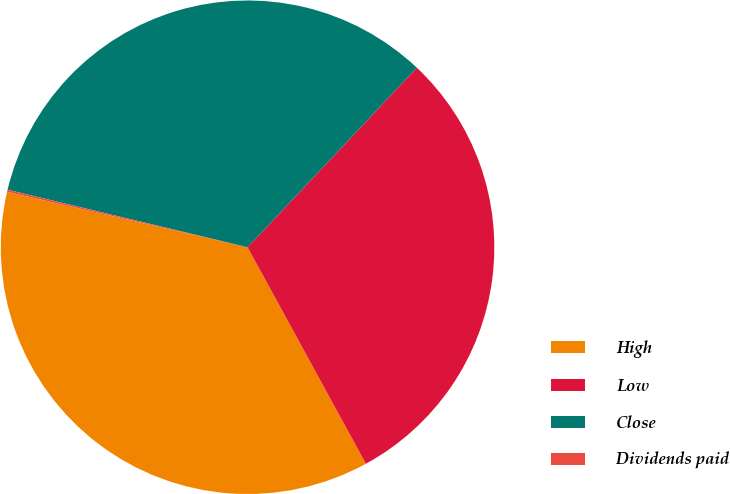<chart> <loc_0><loc_0><loc_500><loc_500><pie_chart><fcel>High<fcel>Low<fcel>Close<fcel>Dividends paid<nl><fcel>36.57%<fcel>30.01%<fcel>33.29%<fcel>0.14%<nl></chart> 